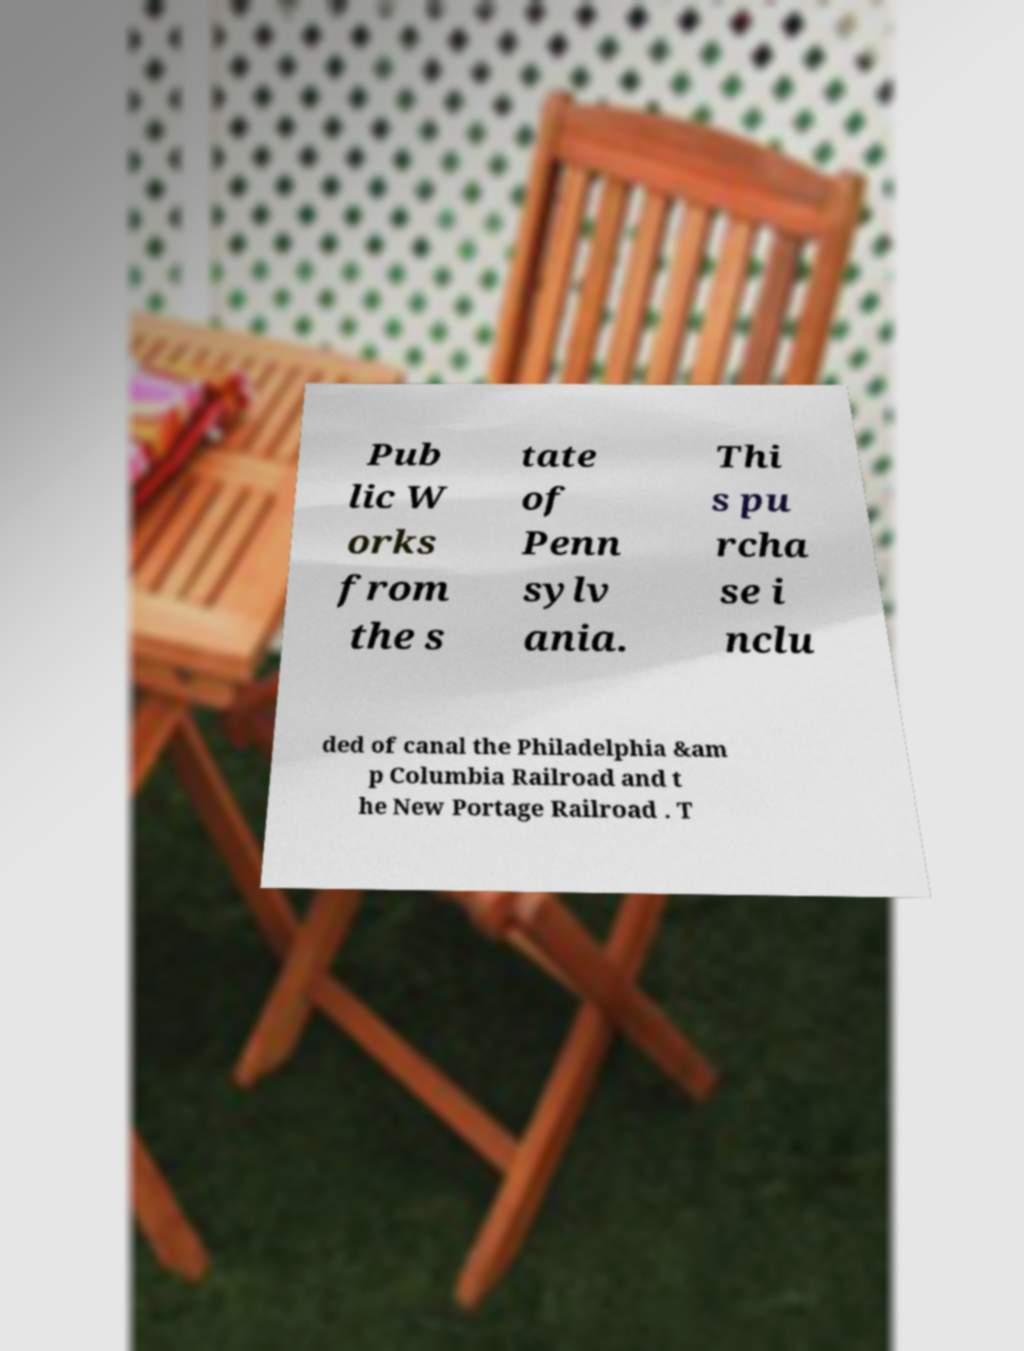What messages or text are displayed in this image? I need them in a readable, typed format. Pub lic W orks from the s tate of Penn sylv ania. Thi s pu rcha se i nclu ded of canal the Philadelphia &am p Columbia Railroad and t he New Portage Railroad . T 